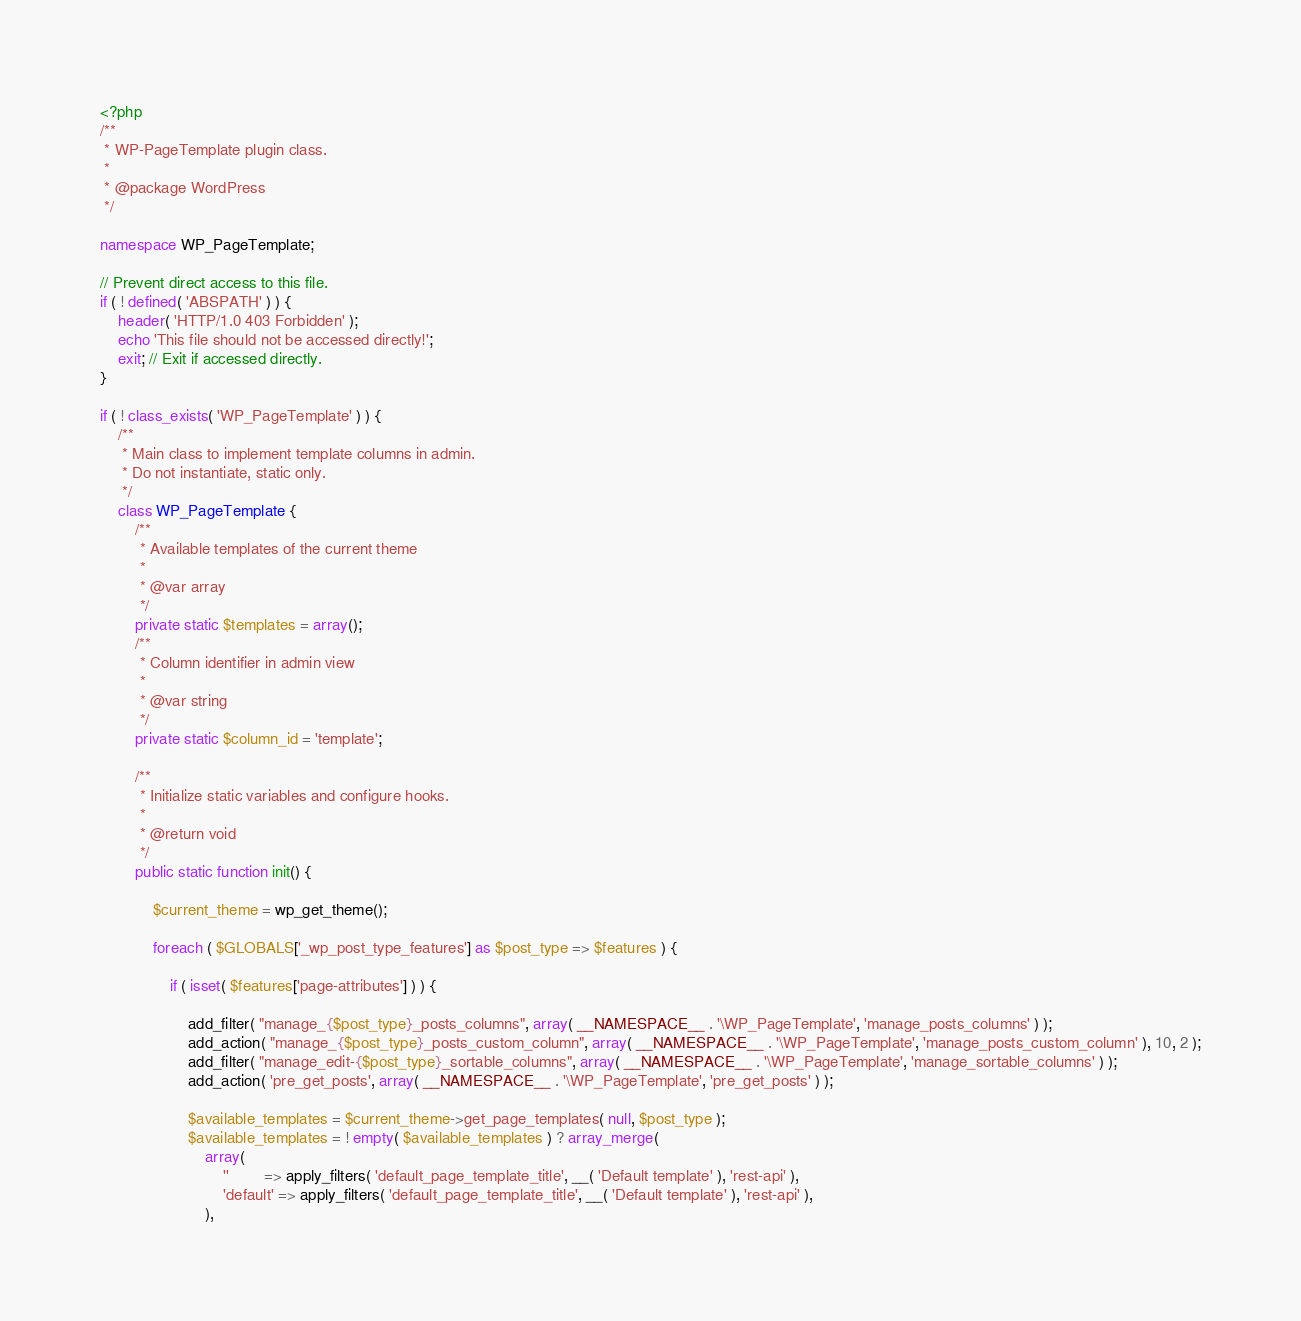<code> <loc_0><loc_0><loc_500><loc_500><_PHP_><?php
/**
 * WP-PageTemplate plugin class.
 *
 * @package WordPress
 */

namespace WP_PageTemplate;

// Prevent direct access to this file.
if ( ! defined( 'ABSPATH' ) ) {
	header( 'HTTP/1.0 403 Forbidden' );
	echo 'This file should not be accessed directly!';
	exit; // Exit if accessed directly.
}

if ( ! class_exists( 'WP_PageTemplate' ) ) {
	/**
	 * Main class to implement template columns in admin.
	 * Do not instantiate, static only.
	 */
	class WP_PageTemplate {
		/**
		 * Available templates of the current theme
		 *
		 * @var array
		 */
		private static $templates = array();
		/**
		 * Column identifier in admin view
		 *
		 * @var string
		 */
		private static $column_id = 'template';

		/**
		 * Initialize static variables and configure hooks.
		 *
		 * @return void
		 */
		public static function init() {

			$current_theme = wp_get_theme();

			foreach ( $GLOBALS['_wp_post_type_features'] as $post_type => $features ) {

				if ( isset( $features['page-attributes'] ) ) {

					add_filter( "manage_{$post_type}_posts_columns", array( __NAMESPACE__ . '\WP_PageTemplate', 'manage_posts_columns' ) );
					add_action( "manage_{$post_type}_posts_custom_column", array( __NAMESPACE__ . '\WP_PageTemplate', 'manage_posts_custom_column' ), 10, 2 );
					add_filter( "manage_edit-{$post_type}_sortable_columns", array( __NAMESPACE__ . '\WP_PageTemplate', 'manage_sortable_columns' ) );
					add_action( 'pre_get_posts', array( __NAMESPACE__ . '\WP_PageTemplate', 'pre_get_posts' ) );

					$available_templates = $current_theme->get_page_templates( null, $post_type );
					$available_templates = ! empty( $available_templates ) ? array_merge(
						array(
							''        => apply_filters( 'default_page_template_title', __( 'Default template' ), 'rest-api' ),
							'default' => apply_filters( 'default_page_template_title', __( 'Default template' ), 'rest-api' ),
						),</code> 